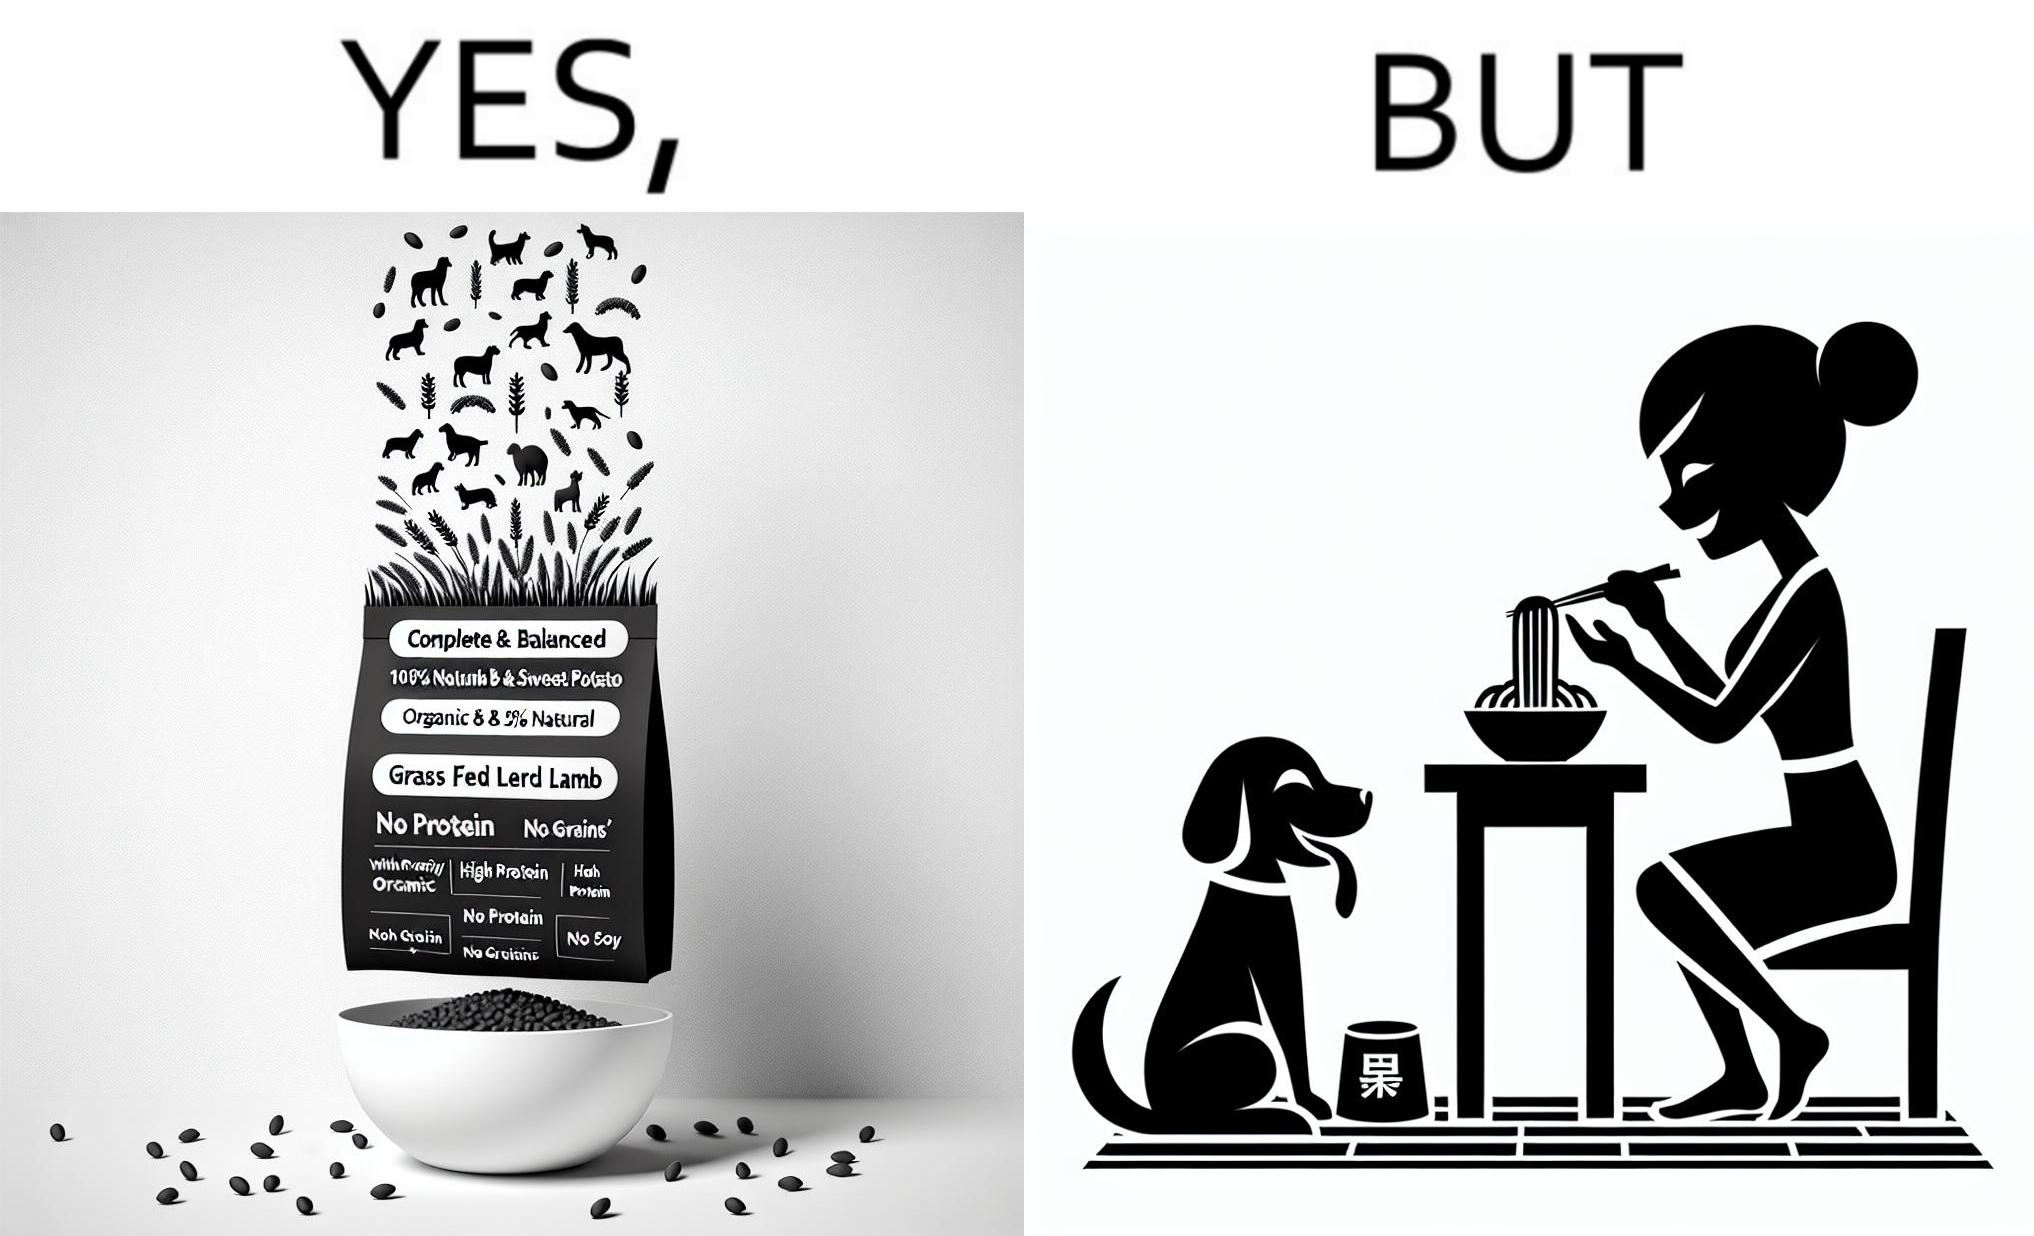What is shown in the left half versus the right half of this image? In the left part of the image: The image shows food grains being poured into a bowl from the packet. The packet says "Complete & Balanced", "Organic", "100% Natural", "Grass Fed Lamb & Sweet Potato" , "With Prebiotic", "High Protein", "No grains", "No Gluten" and "No Soy". In the right part of the image: The image shows a dog eating food from its bowl on the floor and a woman eating noodles from a cup on the table. 